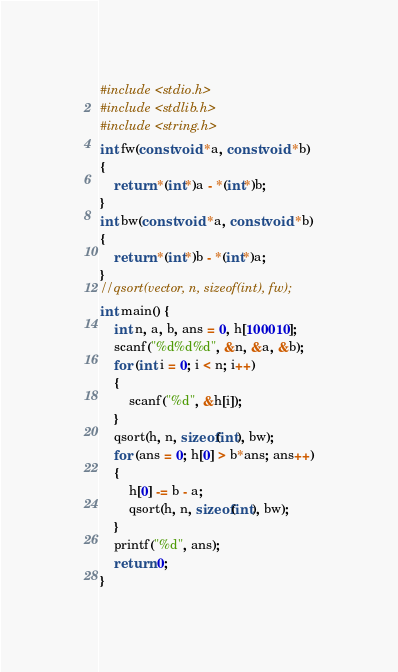<code> <loc_0><loc_0><loc_500><loc_500><_C_>#include <stdio.h>
#include <stdlib.h>
#include <string.h>
int fw(const void *a, const void *b)
{
	return *(int*)a - *(int*)b;
}
int bw(const void *a, const void *b)
{
	return *(int*)b - *(int*)a;
}
//qsort(vector, n, sizeof(int), fw);
int main() {
	int n, a, b, ans = 0, h[100010];
	scanf("%d%d%d", &n, &a, &b);
	for (int i = 0; i < n; i++)
	{
		scanf("%d", &h[i]);
	}
	qsort(h, n, sizeof(int), bw);
	for (ans = 0; h[0] > b*ans; ans++)
	{
		h[0] -= b - a;
		qsort(h, n, sizeof(int), bw);
	}
	printf("%d", ans);
	return 0;
}</code> 